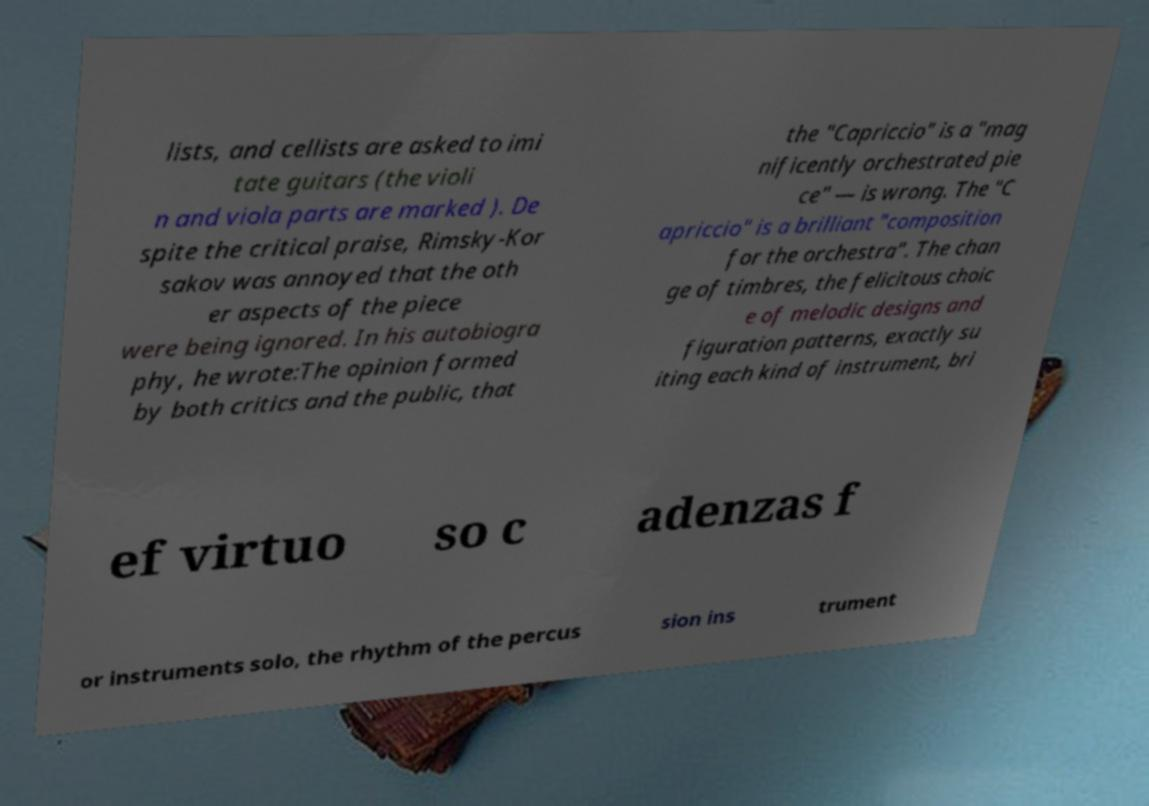Can you read and provide the text displayed in the image?This photo seems to have some interesting text. Can you extract and type it out for me? lists, and cellists are asked to imi tate guitars (the violi n and viola parts are marked ). De spite the critical praise, Rimsky-Kor sakov was annoyed that the oth er aspects of the piece were being ignored. In his autobiogra phy, he wrote:The opinion formed by both critics and the public, that the "Capriccio" is a "mag nificently orchestrated pie ce" — is wrong. The "C apriccio" is a brilliant "composition for the orchestra". The chan ge of timbres, the felicitous choic e of melodic designs and figuration patterns, exactly su iting each kind of instrument, bri ef virtuo so c adenzas f or instruments solo, the rhythm of the percus sion ins trument 